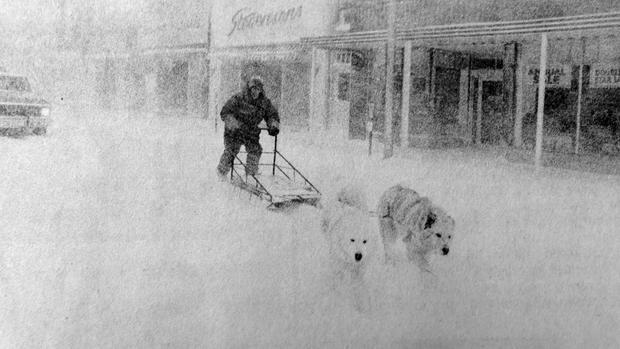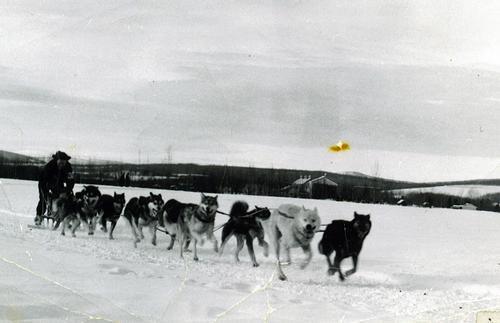The first image is the image on the left, the second image is the image on the right. Given the left and right images, does the statement "One of the images contains no more than two dogs." hold true? Answer yes or no. Yes. 